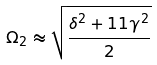Convert formula to latex. <formula><loc_0><loc_0><loc_500><loc_500>\Omega _ { 2 } \approx \sqrt { \frac { \delta ^ { 2 } + 1 1 \gamma ^ { 2 } } { 2 } }</formula> 